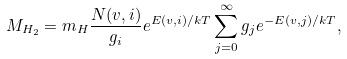<formula> <loc_0><loc_0><loc_500><loc_500>M _ { H _ { 2 } } = m _ { H } \frac { N ( v , i ) } { g _ { i } } e ^ { E ( v , i ) / k T } \sum _ { j = 0 } ^ { \infty } g _ { j } e ^ { - E ( v , j ) / k T } ,</formula> 